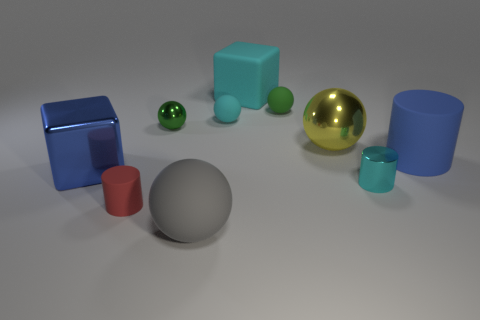Subtract all rubber spheres. How many spheres are left? 2 Subtract all gray blocks. How many green balls are left? 2 Subtract all green balls. How many balls are left? 3 Subtract all cubes. How many objects are left? 8 Add 8 yellow objects. How many yellow objects are left? 9 Add 1 blue metallic blocks. How many blue metallic blocks exist? 2 Subtract 1 yellow balls. How many objects are left? 9 Subtract all purple cylinders. Subtract all yellow cubes. How many cylinders are left? 3 Subtract all green metallic spheres. Subtract all tiny objects. How many objects are left? 4 